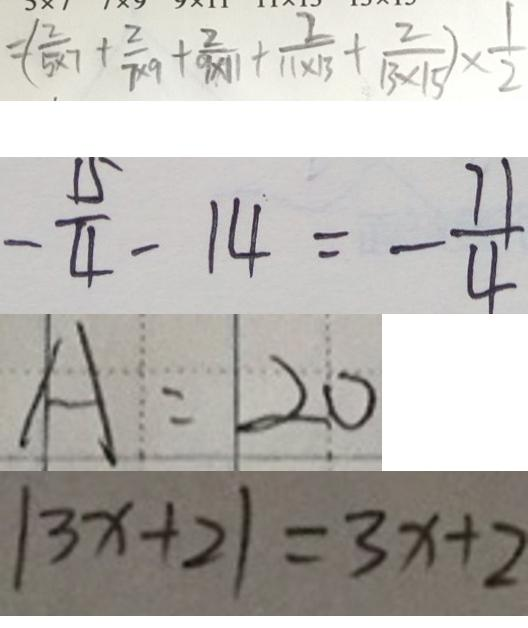<formula> <loc_0><loc_0><loc_500><loc_500>= ( \frac { 2 } { 5 \times 7 } + \frac { 2 } { 7 \times 9 } + \frac { 2 } { 9 \times 1 1 } + \frac { 2 } { 1 1 \times 1 3 } + \frac { 2 } { 1 3 \times 1 5 } ) \times \frac { 1 } { 2 } 
 - \frac { 1 5 } { 4 } - 1 4 = - \frac { 7 1 } { 4 } 
 A : 2 0 
 \vert 3 x + 2 \vert = 3 x + 2</formula> 